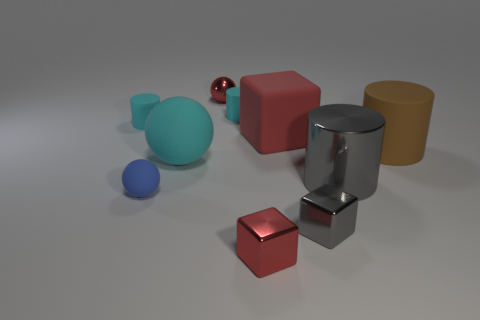Subtract all metal cubes. How many cubes are left? 1 Subtract all gray cylinders. How many cylinders are left? 3 Subtract 1 blocks. How many blocks are left? 2 Subtract all blocks. How many objects are left? 7 Add 4 small shiny balls. How many small shiny balls are left? 5 Add 7 big matte spheres. How many big matte spheres exist? 8 Subtract 1 cyan spheres. How many objects are left? 9 Subtract all brown balls. Subtract all blue cubes. How many balls are left? 3 Subtract all brown cylinders. How many gray cubes are left? 1 Subtract all shiny balls. Subtract all small cyan cylinders. How many objects are left? 7 